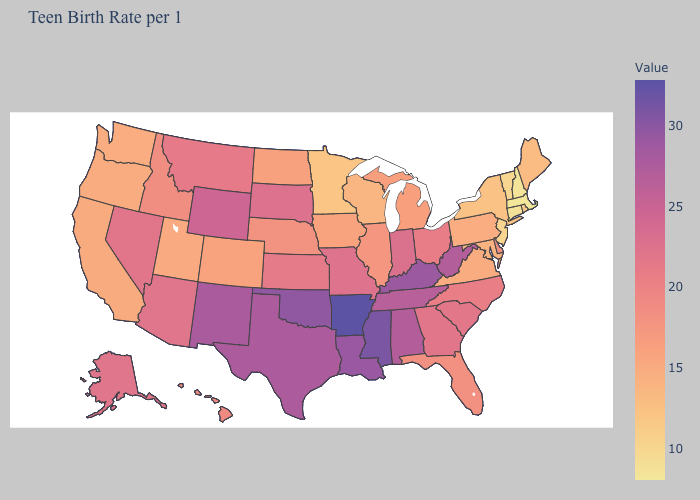Which states hav the highest value in the MidWest?
Concise answer only. Indiana. Which states have the lowest value in the Northeast?
Quick response, please. Massachusetts. Does Massachusetts have the lowest value in the USA?
Concise answer only. Yes. 